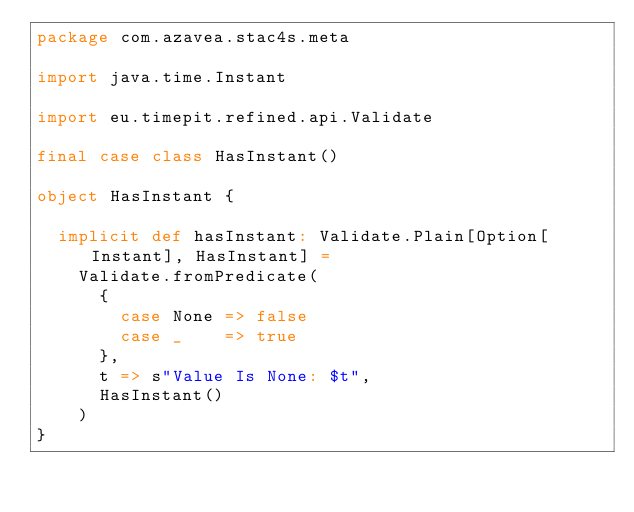Convert code to text. <code><loc_0><loc_0><loc_500><loc_500><_Scala_>package com.azavea.stac4s.meta

import java.time.Instant

import eu.timepit.refined.api.Validate

final case class HasInstant()

object HasInstant {

  implicit def hasInstant: Validate.Plain[Option[Instant], HasInstant] =
    Validate.fromPredicate(
      {
        case None => false
        case _    => true
      },
      t => s"Value Is None: $t",
      HasInstant()
    )
}
</code> 